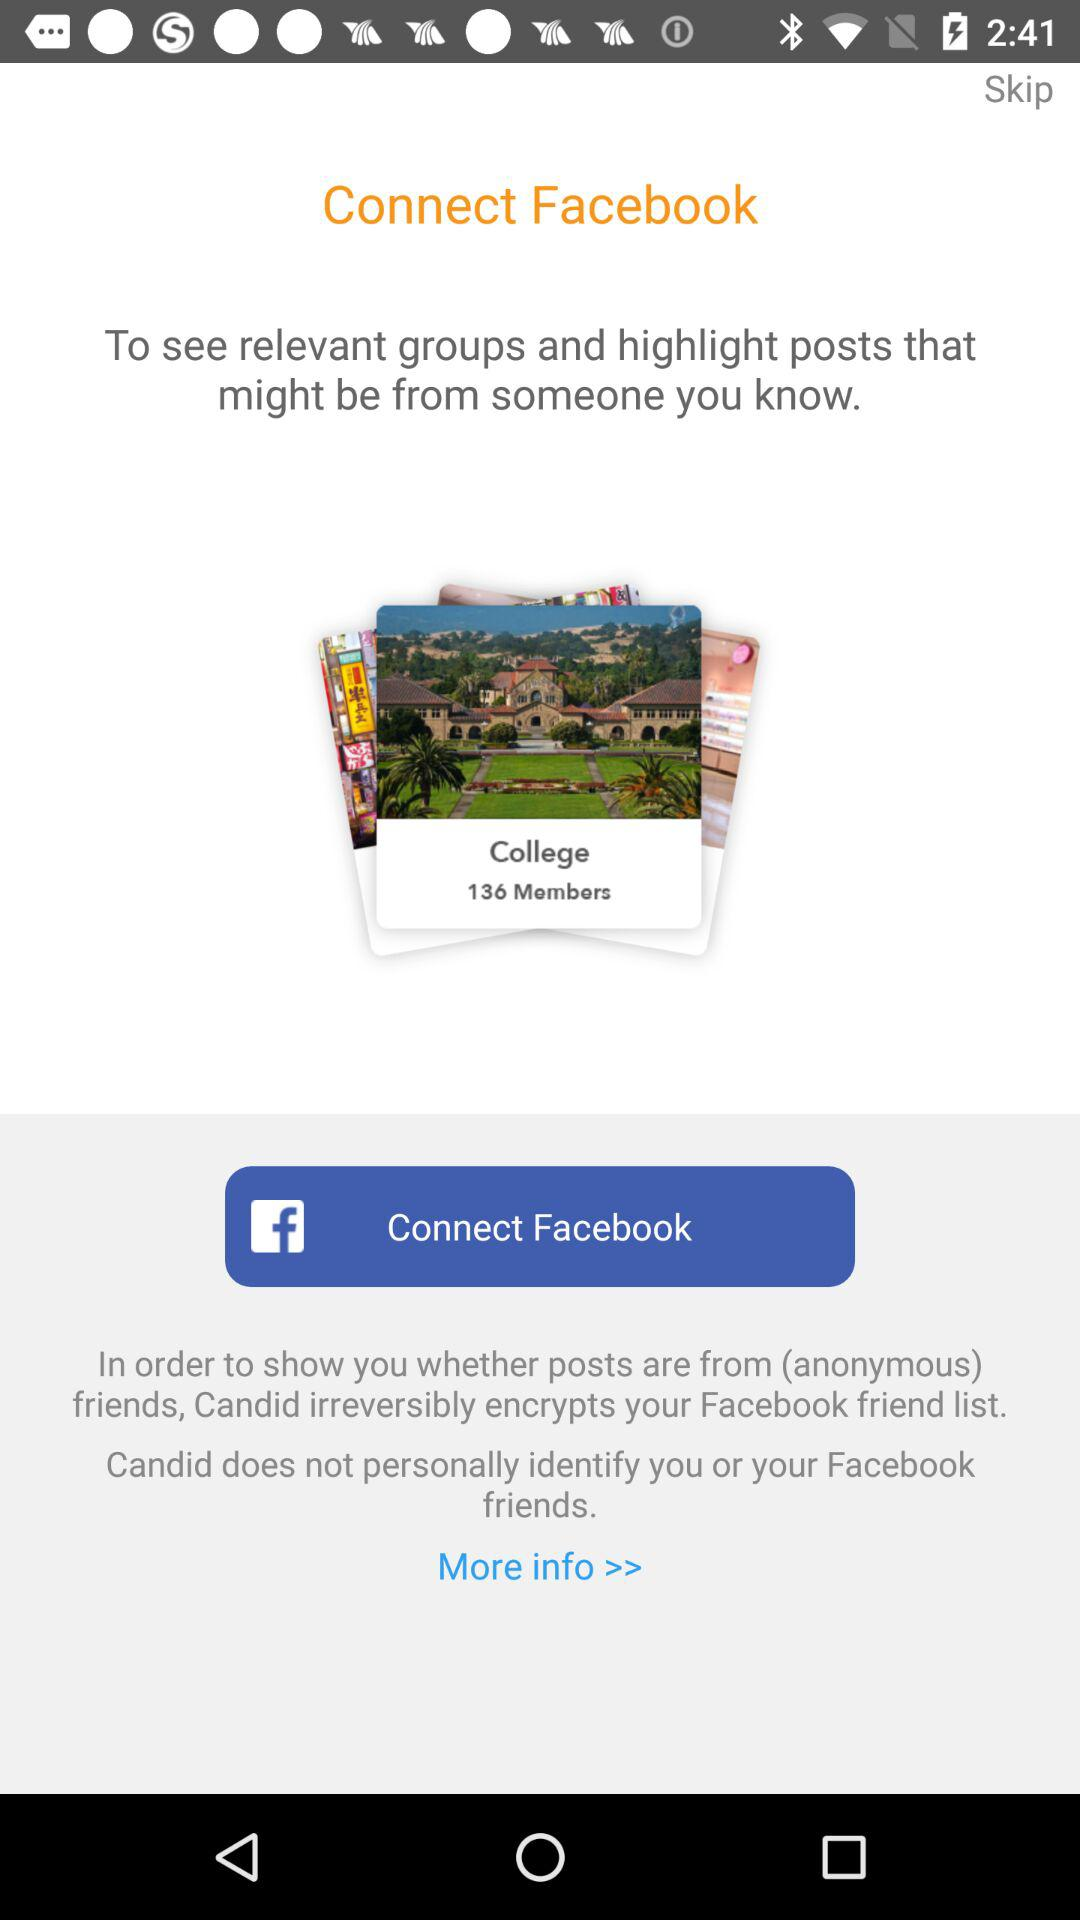How many members are there in "College" profile? There are 136 members. 